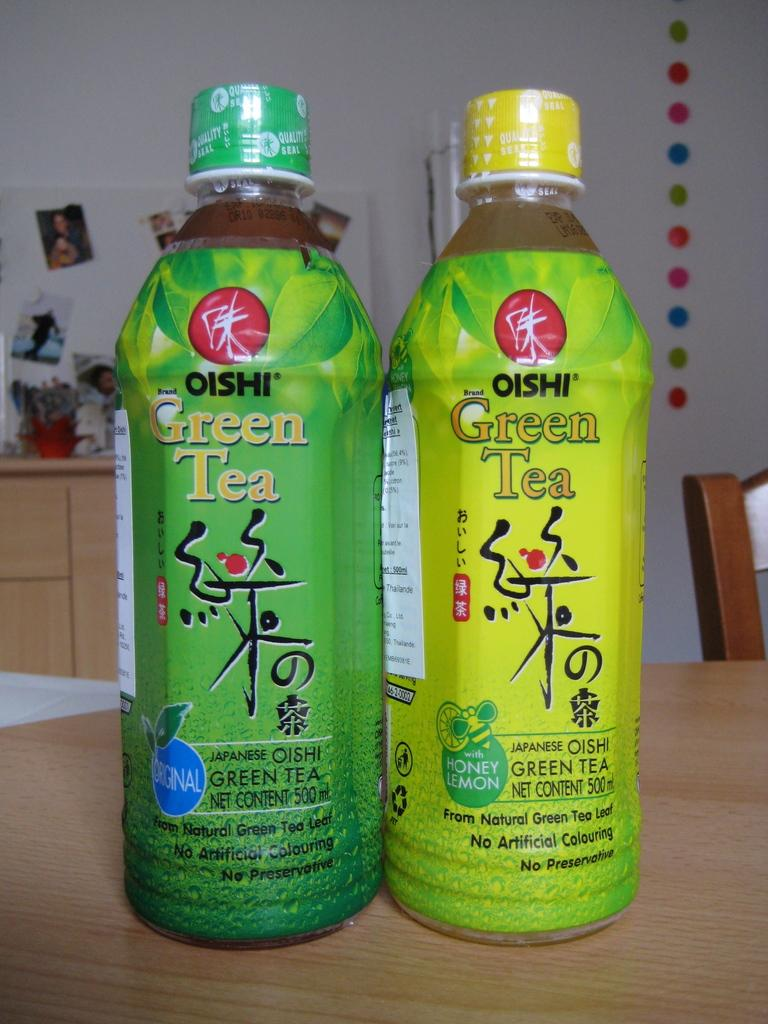Provide a one-sentence caption for the provided image. Two bottles of Oishi green tea sit side by side. 